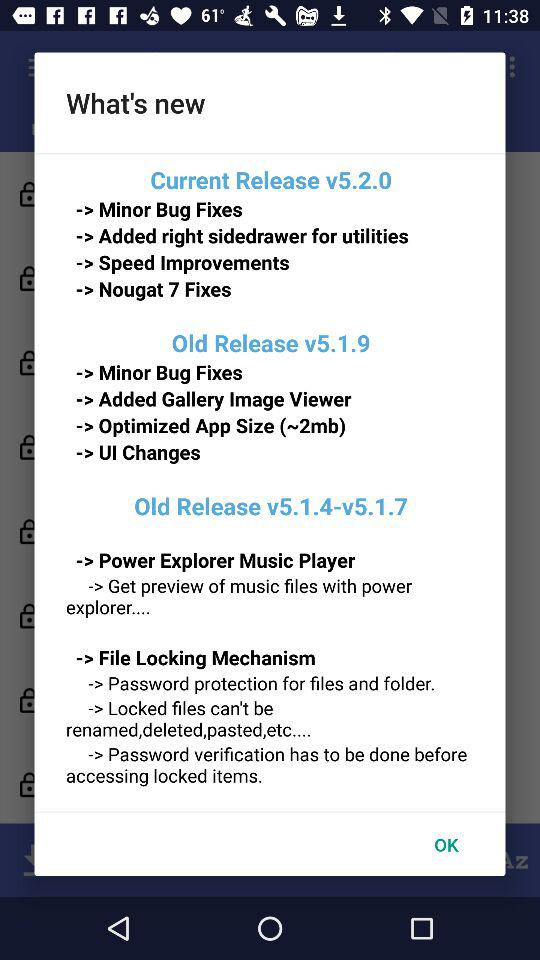Which version has the password protection feature? The version that has the password protection feature is v5.1.4-v5.1.7. 